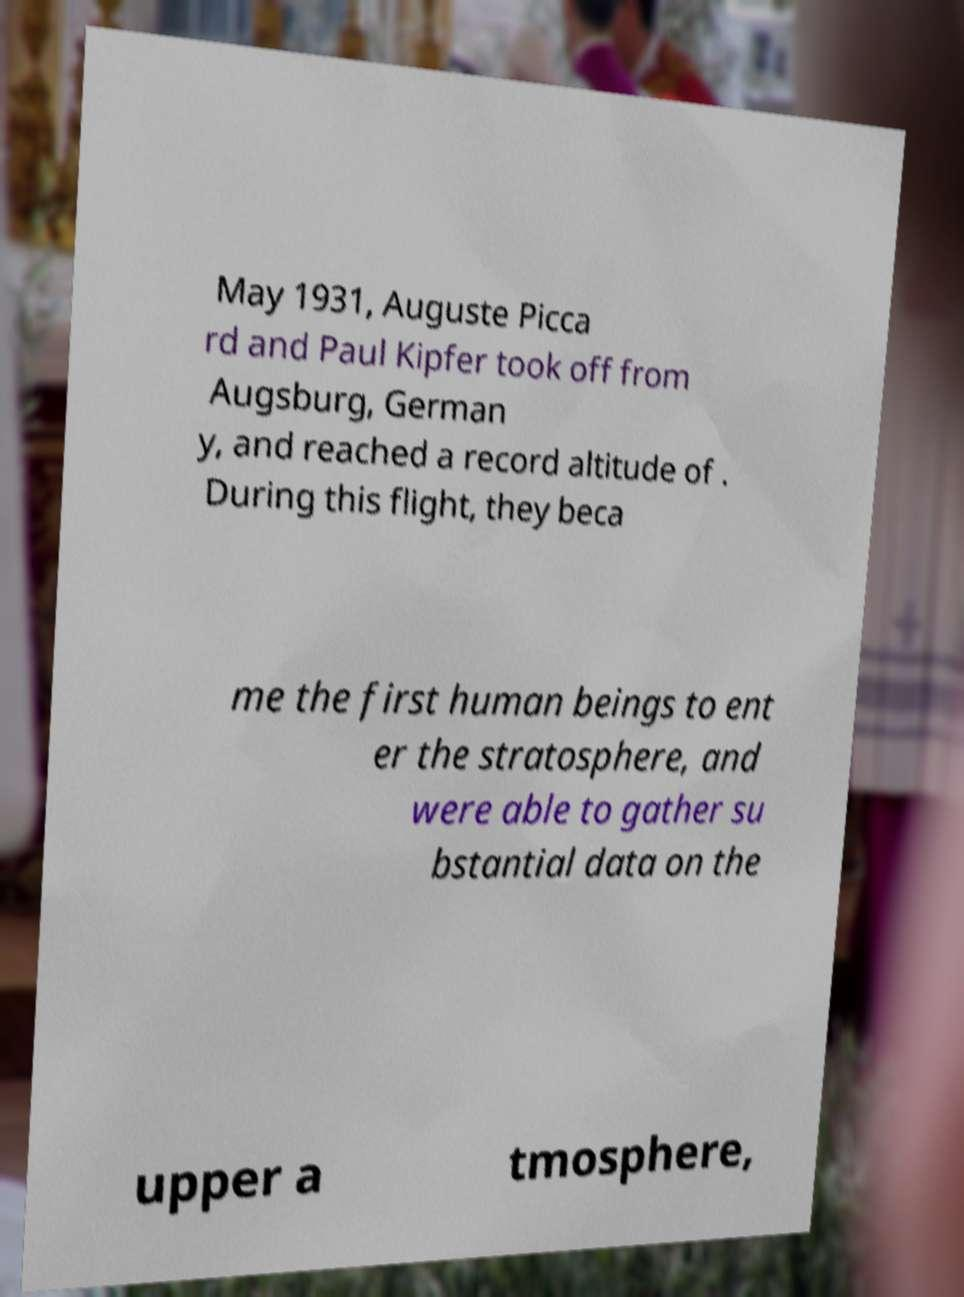I need the written content from this picture converted into text. Can you do that? May 1931, Auguste Picca rd and Paul Kipfer took off from Augsburg, German y, and reached a record altitude of . During this flight, they beca me the first human beings to ent er the stratosphere, and were able to gather su bstantial data on the upper a tmosphere, 